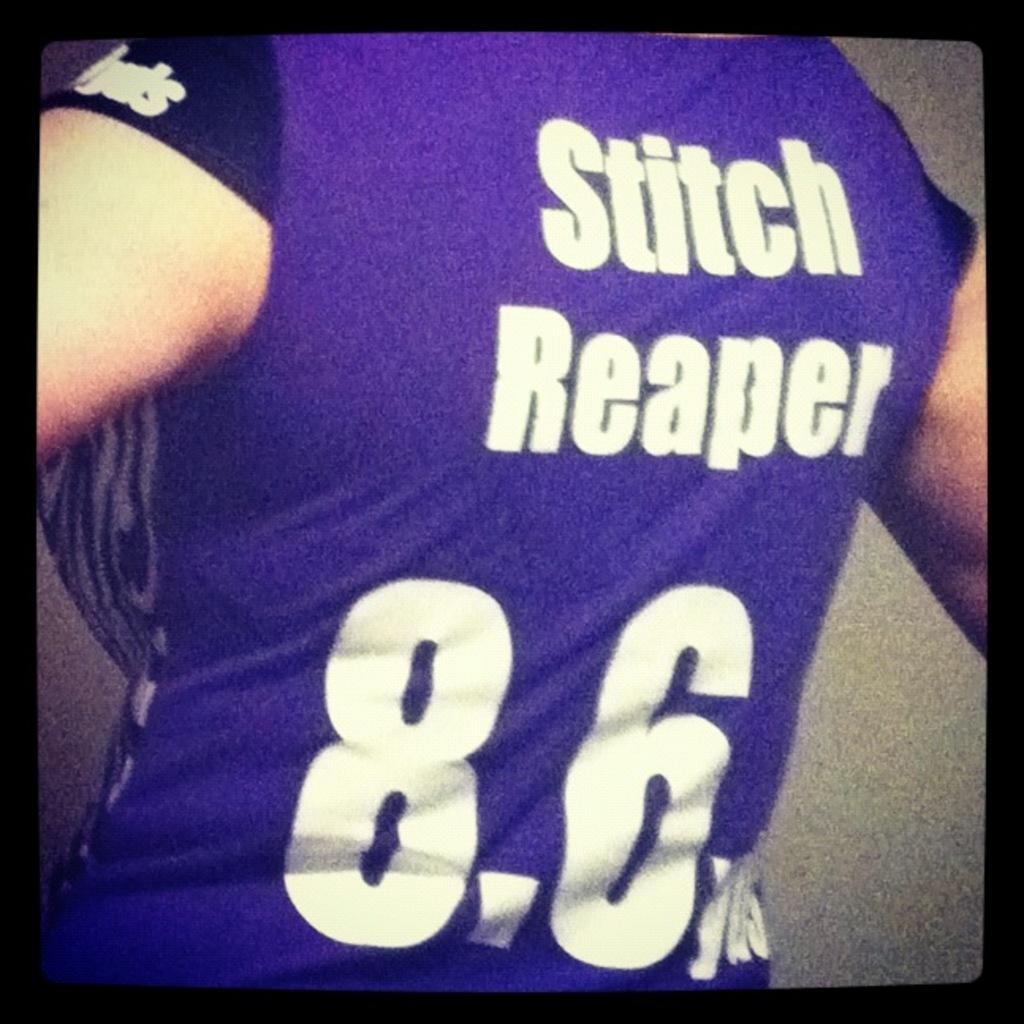<image>
Write a terse but informative summary of the picture. The back of a purple shirt that reads stitch reaper with the number 8.6 on it. 